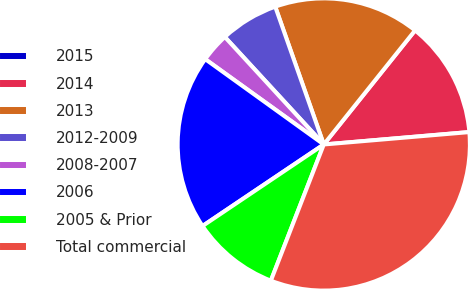Convert chart to OTSL. <chart><loc_0><loc_0><loc_500><loc_500><pie_chart><fcel>2015<fcel>2014<fcel>2013<fcel>2012-2009<fcel>2008-2007<fcel>2006<fcel>2005 & Prior<fcel>Total commercial<nl><fcel>0.01%<fcel>12.9%<fcel>16.13%<fcel>6.45%<fcel>3.23%<fcel>19.35%<fcel>9.68%<fcel>32.25%<nl></chart> 